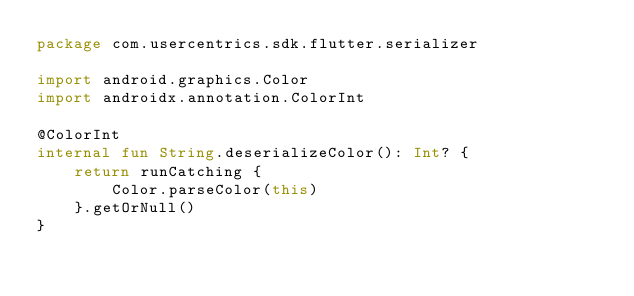<code> <loc_0><loc_0><loc_500><loc_500><_Kotlin_>package com.usercentrics.sdk.flutter.serializer

import android.graphics.Color
import androidx.annotation.ColorInt

@ColorInt
internal fun String.deserializeColor(): Int? {
    return runCatching {
        Color.parseColor(this)
    }.getOrNull()
}</code> 